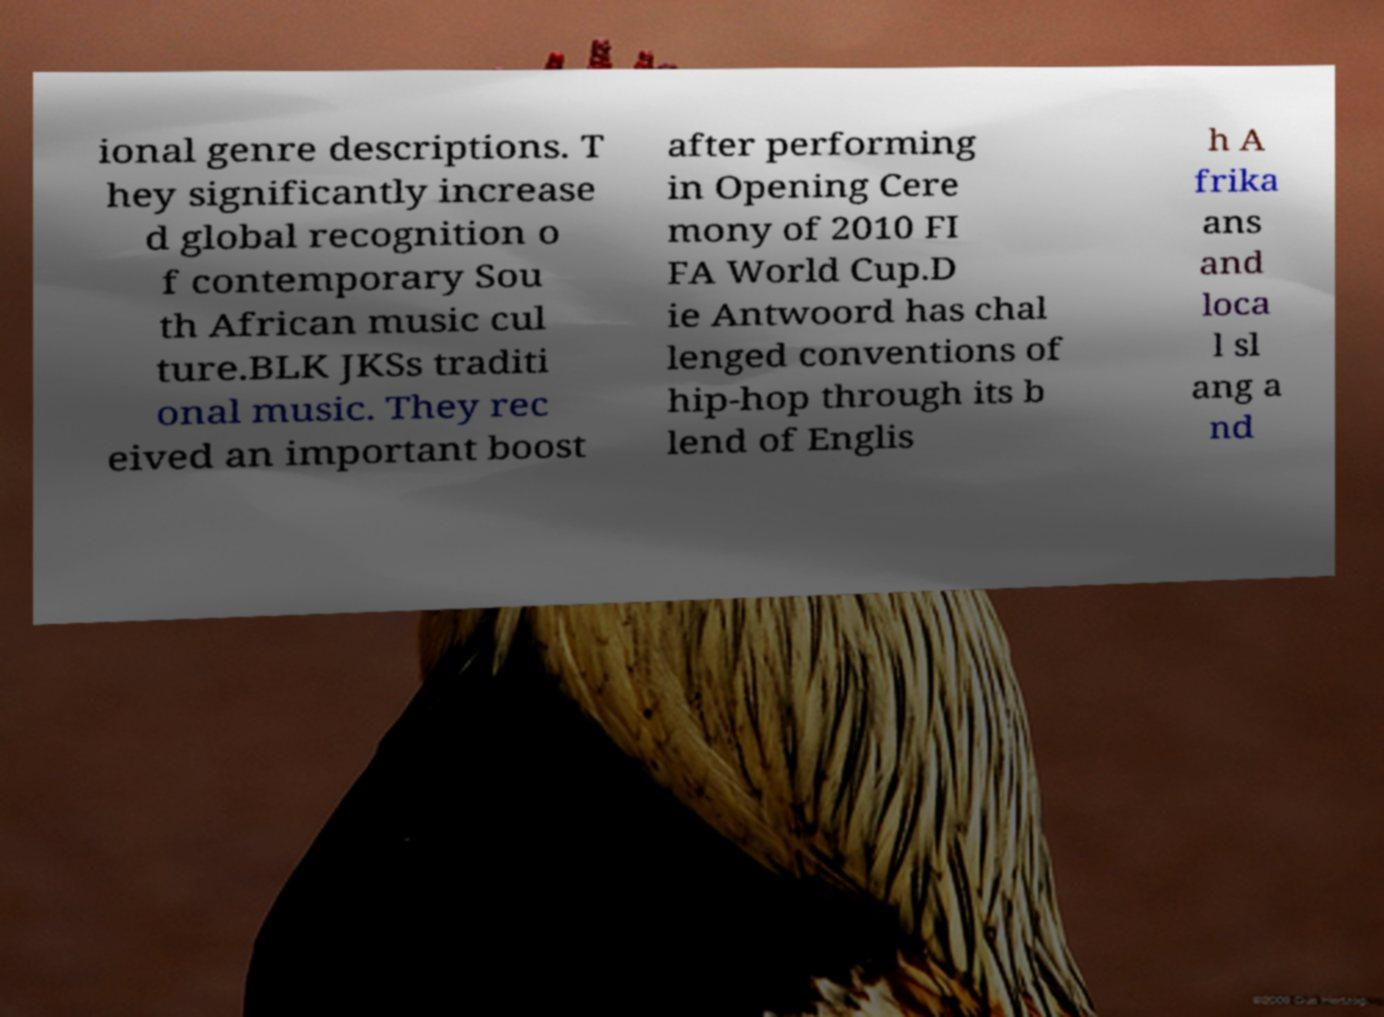Can you read and provide the text displayed in the image?This photo seems to have some interesting text. Can you extract and type it out for me? ional genre descriptions. T hey significantly increase d global recognition o f contemporary Sou th African music cul ture.BLK JKSs traditi onal music. They rec eived an important boost after performing in Opening Cere mony of 2010 FI FA World Cup.D ie Antwoord has chal lenged conventions of hip-hop through its b lend of Englis h A frika ans and loca l sl ang a nd 